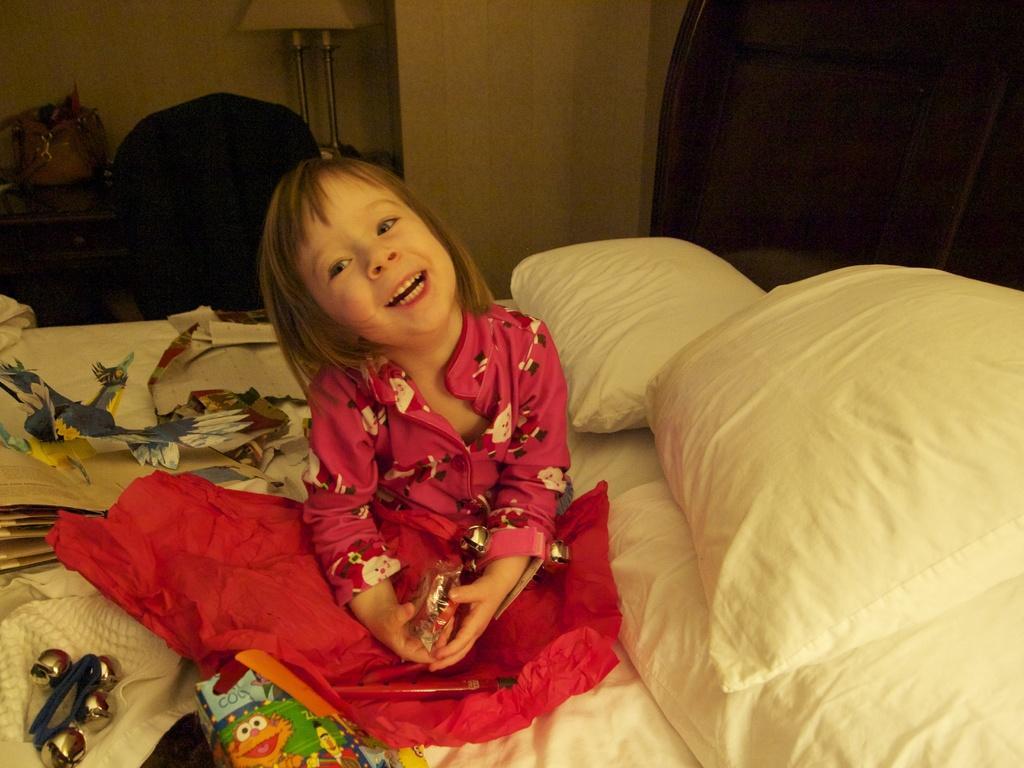In one or two sentences, can you explain what this image depicts? It is a closed room where the bed is present in the middle on that there are pillows and one girl is sitting in a red dress and behind her there is one table and chair and a bag on the table and a bed lamp on it and there is a wall. 